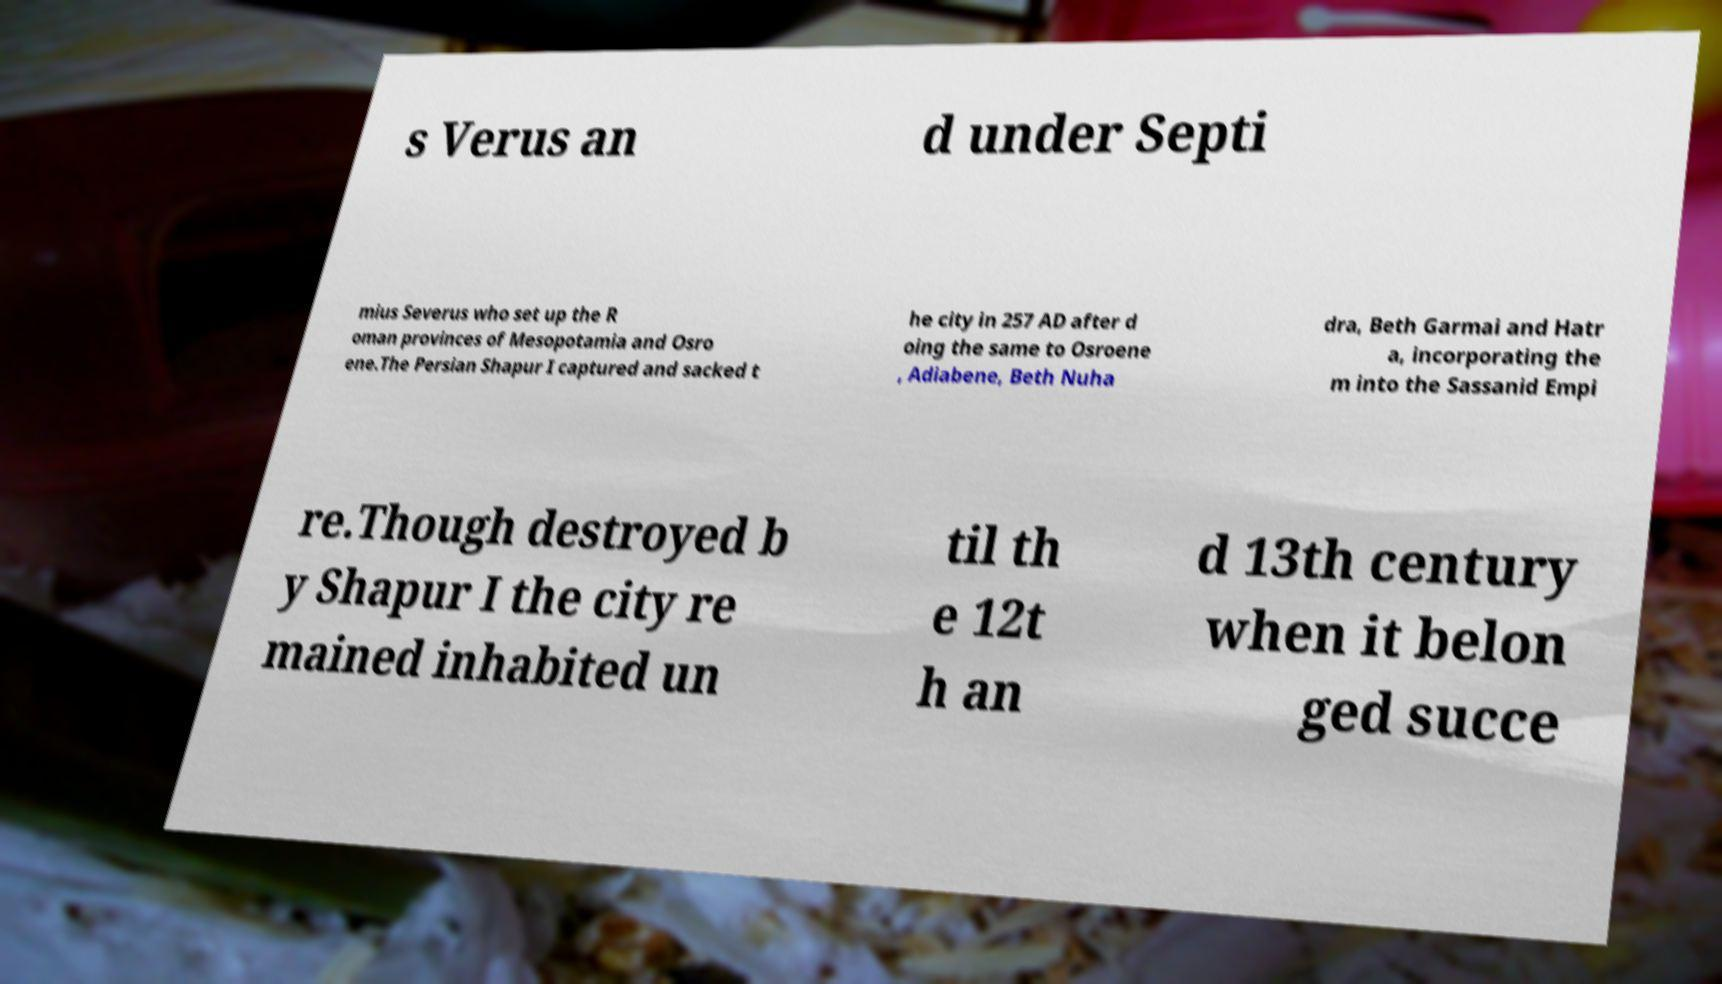Could you assist in decoding the text presented in this image and type it out clearly? s Verus an d under Septi mius Severus who set up the R oman provinces of Mesopotamia and Osro ene.The Persian Shapur I captured and sacked t he city in 257 AD after d oing the same to Osroene , Adiabene, Beth Nuha dra, Beth Garmai and Hatr a, incorporating the m into the Sassanid Empi re.Though destroyed b y Shapur I the city re mained inhabited un til th e 12t h an d 13th century when it belon ged succe 